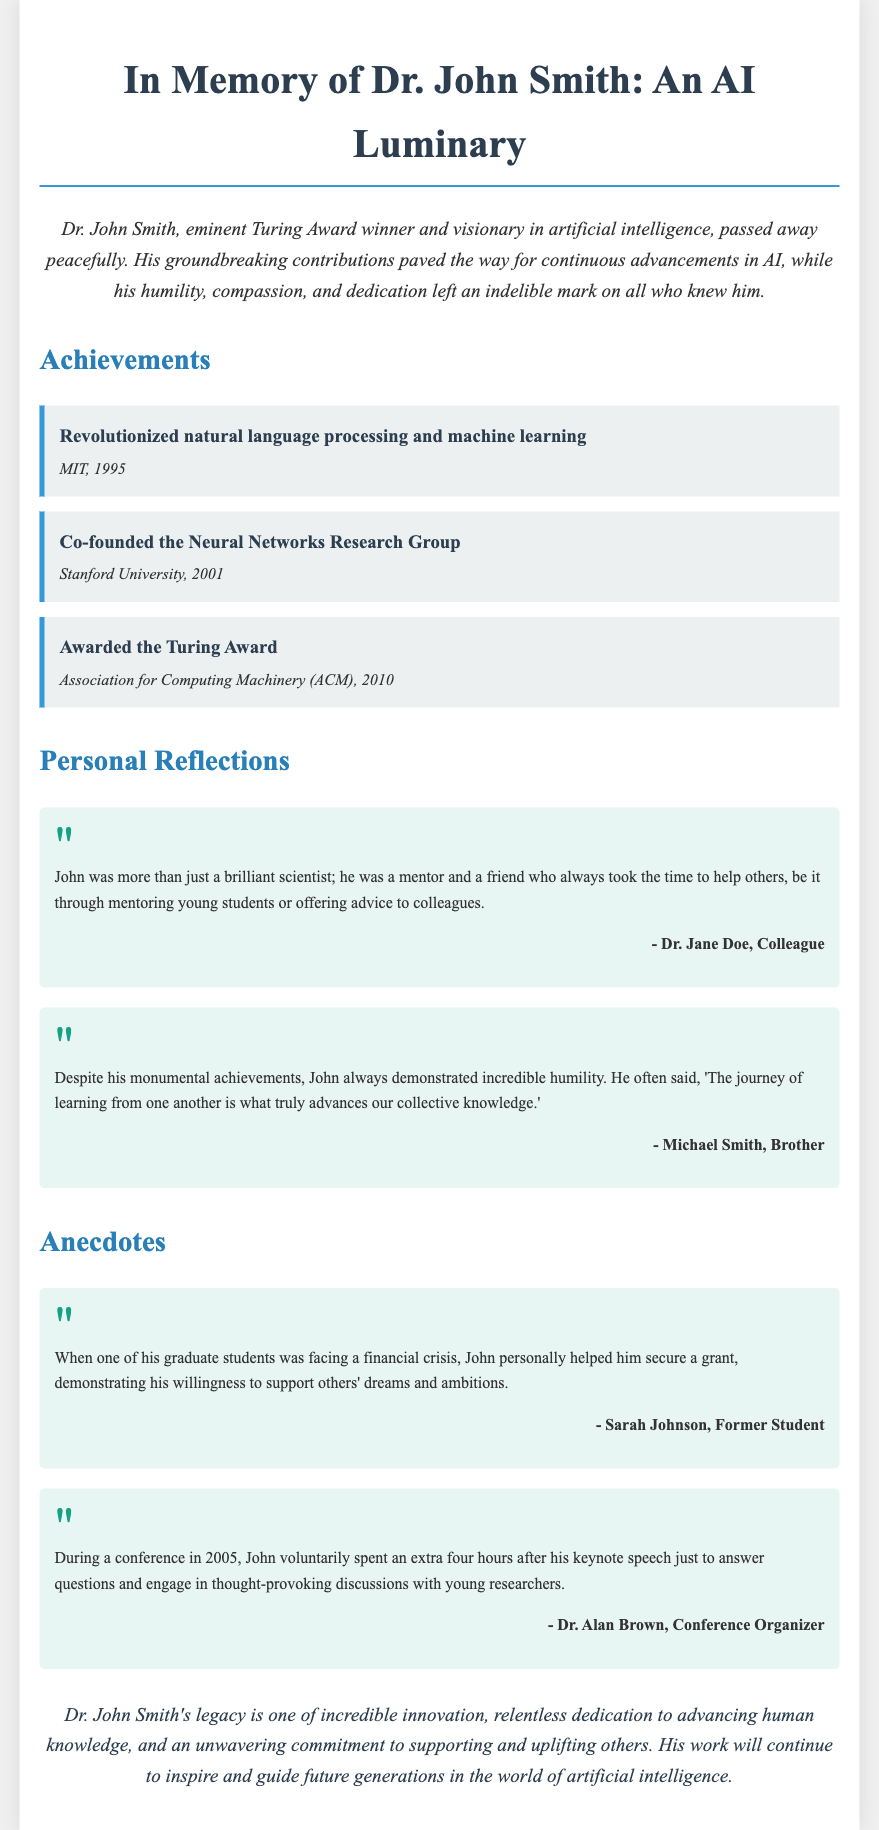What is the title of the obituary? The title of the obituary is "In Memory of Dr. John Smith: An AI Luminary."
Answer: In Memory of Dr. John Smith: An AI Luminary Who was awarded the Turing Award in 2010? The document states that Dr. John Smith was awarded the Turing Award in 2010.
Answer: Dr. John Smith What year did Dr. John Smith co-found the Neural Networks Research Group? The document mentions that Dr. John Smith co-founded the Neural Networks Research Group in 2001.
Answer: 2001 What is one quality that Dr. John Smith demonstrated despite his achievements? The document highlights that Dr. John Smith demonstrated humility despite his achievements.
Answer: Humility Who described Dr. John Smith as a mentor and friend? Dr. Jane Doe, a colleague, described Dr. John Smith as a mentor and friend.
Answer: Dr. Jane Doe Which event did Dr. John Smith attend in 2005? The document mentions that Dr. John Smith attended a conference in 2005.
Answer: Conference in 2005 What did John help secure for his graduate student? The document states that John helped his graduate student secure a grant.
Answer: Grant What type of legacy did Dr. John Smith leave behind? The document states that Dr. John Smith's legacy is one of incredible innovation and support for others.
Answer: Incredible innovation and support for others 